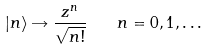<formula> <loc_0><loc_0><loc_500><loc_500>| n \rangle \rightarrow \frac { z ^ { n } } { \sqrt { n ! } } \quad n = 0 , 1 , \dots</formula> 